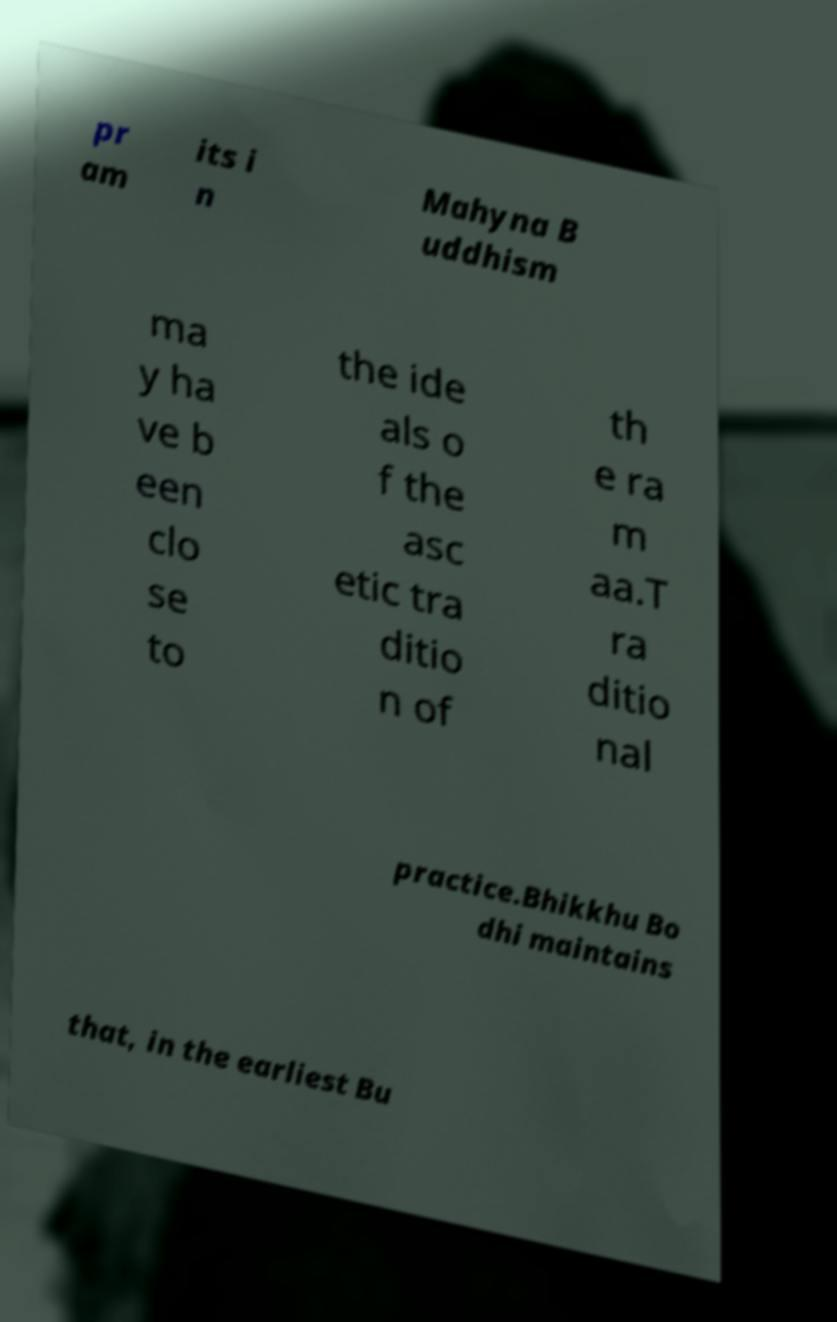Could you assist in decoding the text presented in this image and type it out clearly? pr am its i n Mahyna B uddhism ma y ha ve b een clo se to the ide als o f the asc etic tra ditio n of th e ra m aa.T ra ditio nal practice.Bhikkhu Bo dhi maintains that, in the earliest Bu 